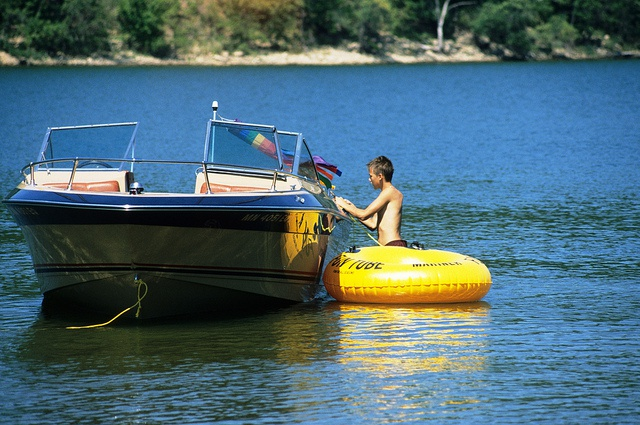Describe the objects in this image and their specific colors. I can see boat in black, gray, ivory, and blue tones, boat in black, yellow, red, and khaki tones, people in black, khaki, tan, and beige tones, and kite in black, gray, and blue tones in this image. 